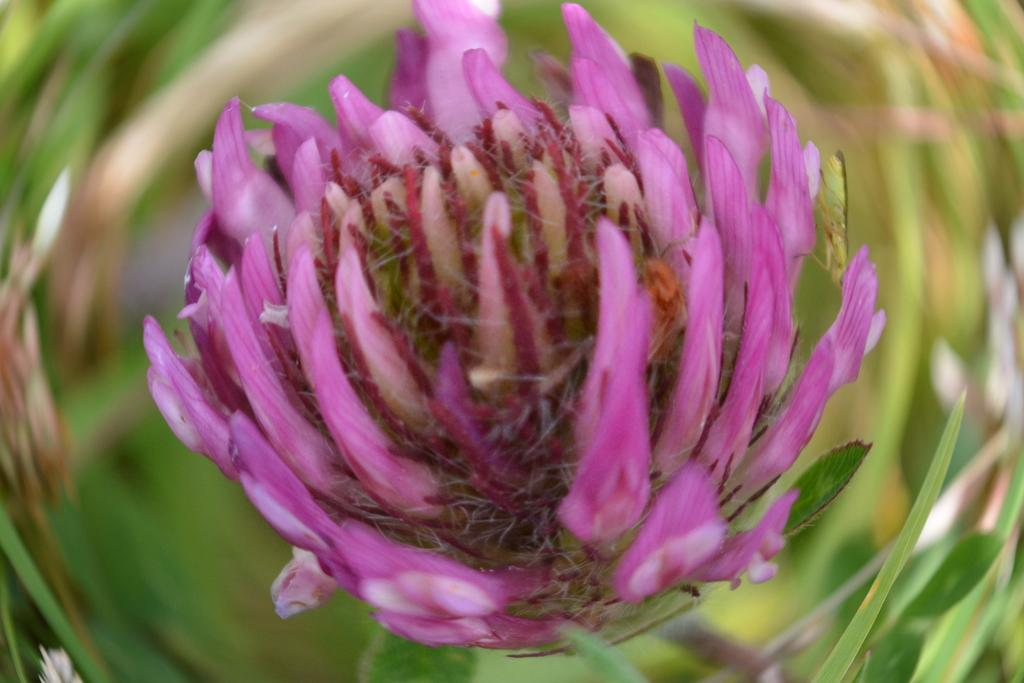What is the main subject of the image? There is a flower in the image. Can you describe the color of the flower? The flower is pale pink in color. Are there any other parts of the plant visible in the image? Yes, there are leaves associated with the flower. How would you describe the background of the image? The background of the image is blurred. What type of punishment is being administered to the flower in the image? There is no punishment being administered to the flower in the image; it is a still image of a flower. Can you tell me the name of the minister who is present in the image? There is no minister present in the image; it features a flower and leaves. 